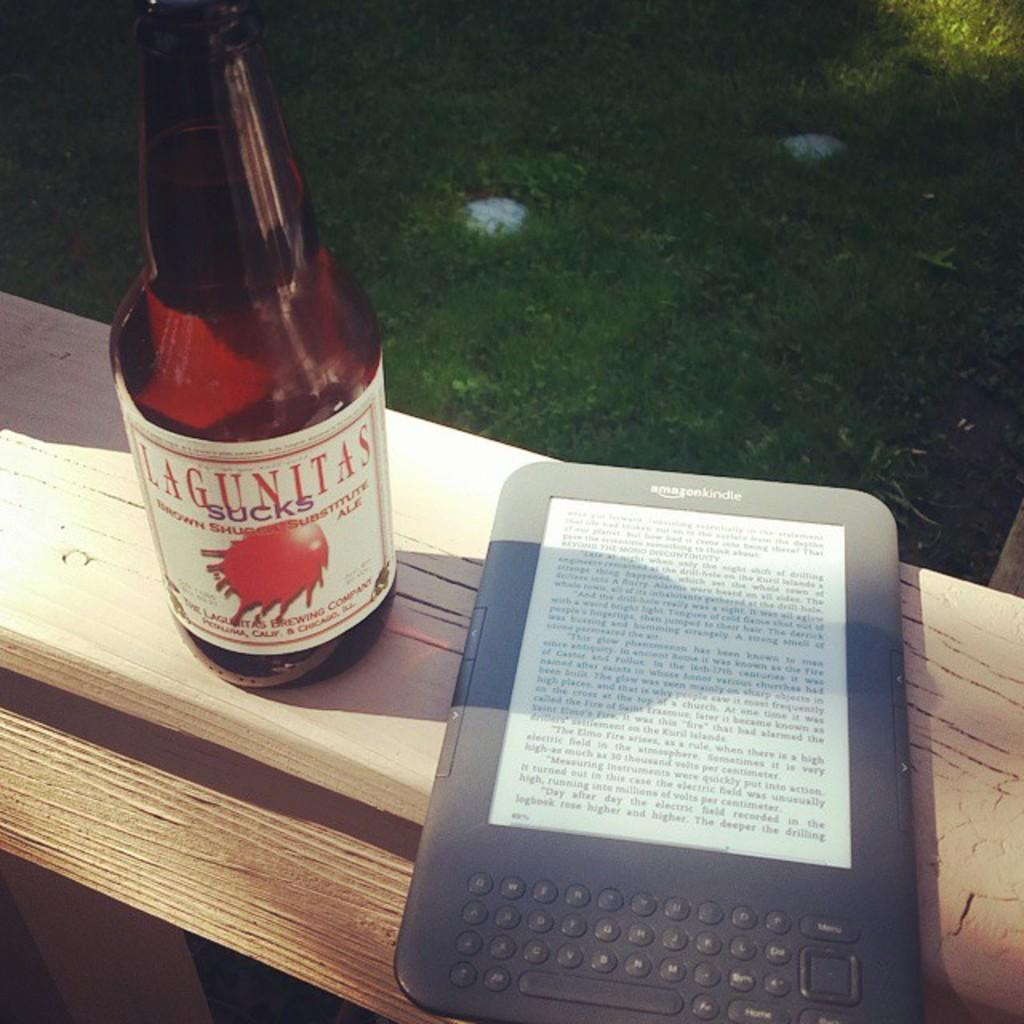What type of object is the electronic gadget in the image? The electronic gadget in the image is not specified, but it is an object that uses electricity to function. What is contained in the glass in the image? The glass in the image contains liquid. Where is the glass located in the image? The glass is on a bench in the image. What can be seen in the background of the image? There is grass visible in the background of the image. What type of fowl can be seen walking on the bench in the image? There is no fowl present in the image; the glass is on a bench with grass visible in the background. 